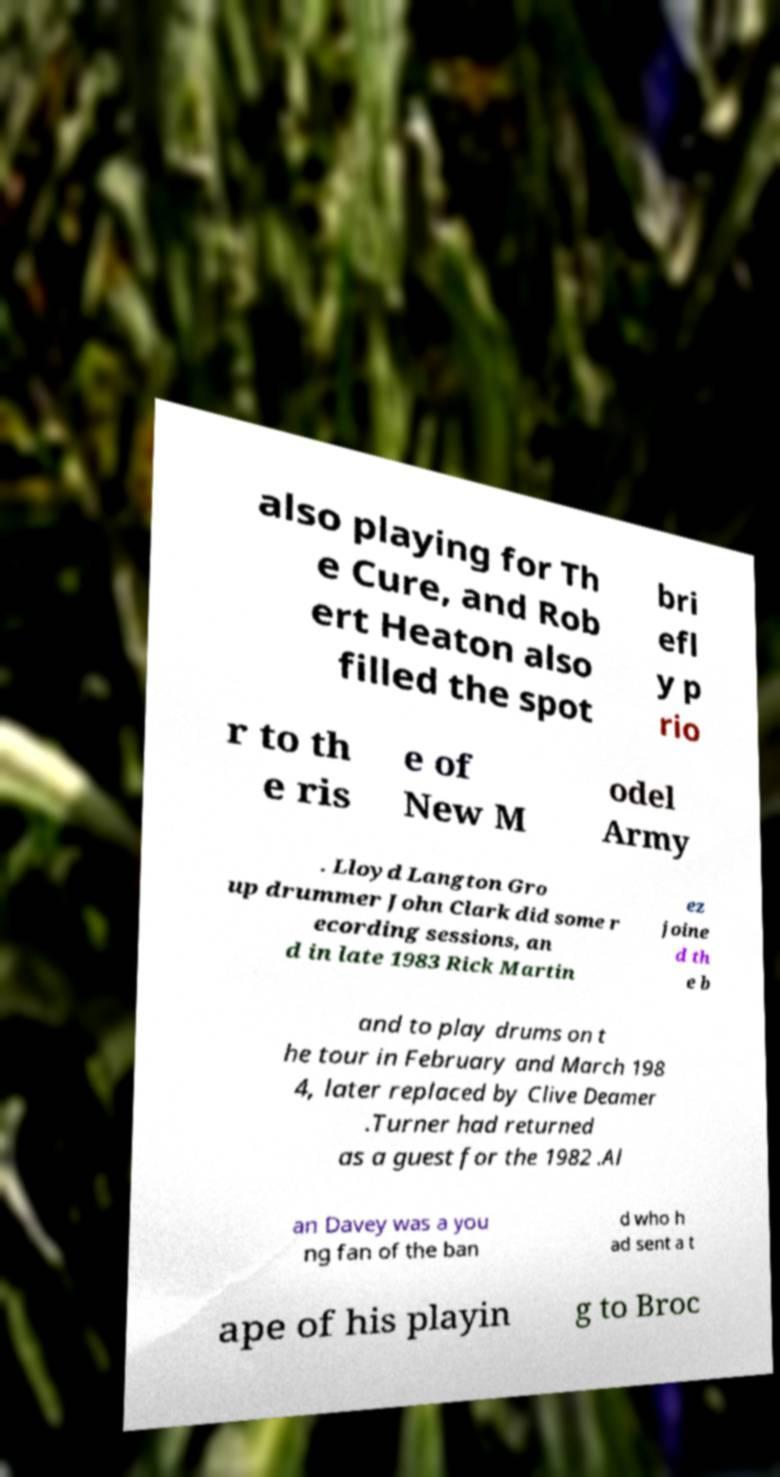Can you accurately transcribe the text from the provided image for me? also playing for Th e Cure, and Rob ert Heaton also filled the spot bri efl y p rio r to th e ris e of New M odel Army . Lloyd Langton Gro up drummer John Clark did some r ecording sessions, an d in late 1983 Rick Martin ez joine d th e b and to play drums on t he tour in February and March 198 4, later replaced by Clive Deamer .Turner had returned as a guest for the 1982 .Al an Davey was a you ng fan of the ban d who h ad sent a t ape of his playin g to Broc 